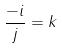<formula> <loc_0><loc_0><loc_500><loc_500>\frac { - i } { j } = k</formula> 